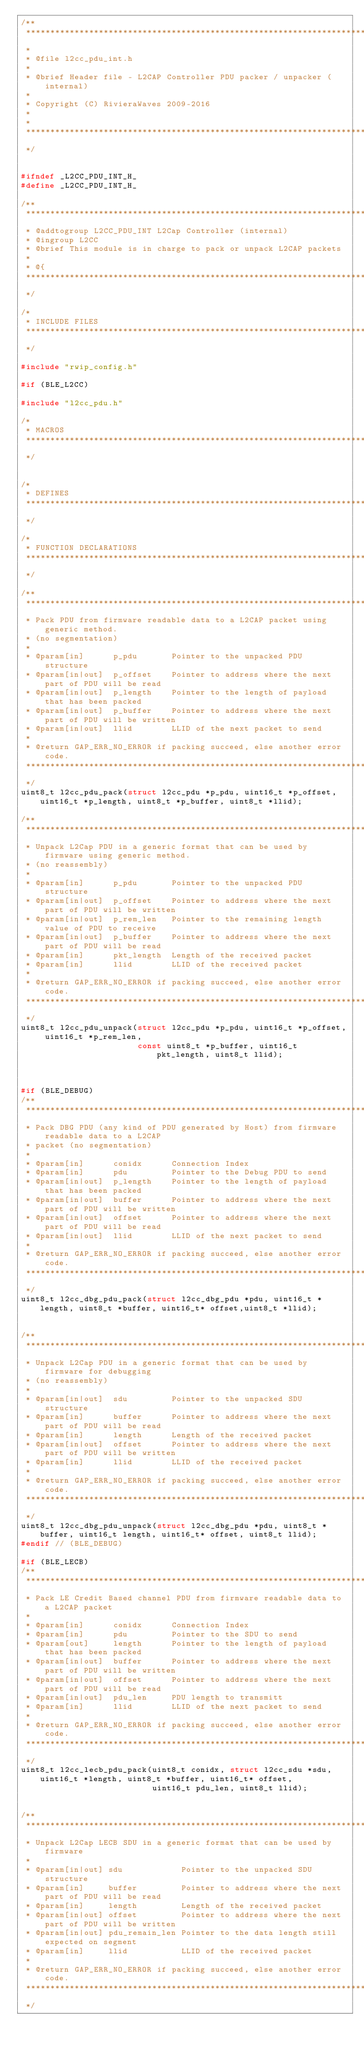<code> <loc_0><loc_0><loc_500><loc_500><_C_>/**
 ****************************************************************************************
 *
 * @file l2cc_pdu_int.h
 *
 * @brief Header file - L2CAP Controller PDU packer / unpacker (internal)
 *
 * Copyright (C) RivieraWaves 2009-2016
 *
 *
 ****************************************************************************************
 */


#ifndef _L2CC_PDU_INT_H_
#define _L2CC_PDU_INT_H_

/**
 ****************************************************************************************
 * @addtogroup L2CC_PDU_INT L2Cap Controller (internal)
 * @ingroup L2CC
 * @brief This module is in charge to pack or unpack L2CAP packets
 *
 * @{
 ****************************************************************************************
 */

/*
 * INCLUDE FILES
 ****************************************************************************************
 */

#include "rwip_config.h"

#if (BLE_L2CC)

#include "l2cc_pdu.h"

/*
 * MACROS
 ****************************************************************************************
 */


/*
 * DEFINES
 ****************************************************************************************
 */

/*
 * FUNCTION DECLARATIONS
 ****************************************************************************************
 */

/**
 ****************************************************************************************
 * Pack PDU from firmware readable data to a L2CAP packet using generic method.
 * (no segmentation)
 *
 * @param[in]      p_pdu       Pointer to the unpacked PDU structure
 * @param[in|out]  p_offset    Pointer to address where the next part of PDU will be read
 * @param[in|out]  p_length    Pointer to the length of payload that has been packed
 * @param[in|out]  p_buffer    Pointer to address where the next part of PDU will be written
 * @param[in|out]  llid        LLID of the next packet to send
 *
 * @return GAP_ERR_NO_ERROR if packing succeed, else another error code.
 ****************************************************************************************
 */
uint8_t l2cc_pdu_pack(struct l2cc_pdu *p_pdu, uint16_t *p_offset, uint16_t *p_length, uint8_t *p_buffer, uint8_t *llid);

/**
 ****************************************************************************************
 * Unpack L2Cap PDU in a generic format that can be used by firmware using generic method.
 * (no reassembly)
 *
 * @param[in]      p_pdu       Pointer to the unpacked PDU structure
 * @param[in|out]  p_offset    Pointer to address where the next part of PDU will be written
 * @param[in|out]  p_rem_len   Pointer to the remaining length value of PDU to receive
 * @param[in|out]  p_buffer    Pointer to address where the next part of PDU will be read
 * @param[in]      pkt_length  Length of the received packet
 * @param[in]      llid        LLID of the received packet
 *
 * @return GAP_ERR_NO_ERROR if packing succeed, else another error code.
 ****************************************************************************************
 */
uint8_t l2cc_pdu_unpack(struct l2cc_pdu *p_pdu, uint16_t *p_offset, uint16_t *p_rem_len,
                        const uint8_t *p_buffer, uint16_t pkt_length, uint8_t llid);



#if (BLE_DEBUG)
/**
 ****************************************************************************************
 * Pack DBG PDU (any kind of PDU generated by Host) from firmware readable data to a L2CAP
 * packet (no segmentation)
 *
 * @param[in]      conidx      Connection Index
 * @param[in]      pdu         Pointer to the Debug PDU to send
 * @param[in|out]  p_length    Pointer to the length of payload that has been packed
 * @param[in|out]  buffer      Pointer to address where the next part of PDU will be written
 * @param[in|out]  offset      Pointer to address where the next part of PDU will be read
 * @param[in|out]  llid        LLID of the next packet to send
 *
 * @return GAP_ERR_NO_ERROR if packing succeed, else another error code.
 ****************************************************************************************
 */
uint8_t l2cc_dbg_pdu_pack(struct l2cc_dbg_pdu *pdu, uint16_t *length, uint8_t *buffer, uint16_t* offset,uint8_t *llid);


/**
 ****************************************************************************************
 * Unpack L2Cap PDU in a generic format that can be used by firmware for debugging
 * (no reassembly)
 *
 * @param[in|out]  sdu         Pointer to the unpacked SDU structure
 * @param[in]      buffer      Pointer to address where the next part of PDU will be read
 * @param[in]      length      Length of the received packet
 * @param[in|out]  offset      Pointer to address where the next part of PDU will be written
 * @param[in]      llid        LLID of the received packet
 *
 * @return GAP_ERR_NO_ERROR if packing succeed, else another error code.
 ****************************************************************************************
 */
uint8_t l2cc_dbg_pdu_unpack(struct l2cc_dbg_pdu *pdu, uint8_t *buffer, uint16_t length, uint16_t* offset, uint8_t llid);
#endif // (BLE_DEBUG)

#if (BLE_LECB)
/**
 ****************************************************************************************
 * Pack LE Credit Based channel PDU from firmware readable data to a L2CAP packet
 *
 * @param[in]      conidx      Connection Index
 * @param[in]      pdu         Pointer to the SDU to send
 * @param[out]     length      Pointer to the length of payload that has been packed
 * @param[in|out]  buffer      Pointer to address where the next part of PDU will be written
 * @param[in|out]  offset      Pointer to address where the next part of PDU will be read
 * @param[in|out]  pdu_len     PDU length to transmitt
 * @param[in]      llid        LLID of the next packet to send
 *
 * @return GAP_ERR_NO_ERROR if packing succeed, else another error code.
 ****************************************************************************************
 */
uint8_t l2cc_lecb_pdu_pack(uint8_t conidx, struct l2cc_sdu *sdu, uint16_t *length, uint8_t *buffer, uint16_t* offset,
                           uint16_t pdu_len, uint8_t llid);


/**
 ****************************************************************************************
 * Unpack L2Cap LECB SDU in a generic format that can be used by firmware
 *
 * @param[in|out] sdu            Pointer to the unpacked SDU structure
 * @param[in]     buffer         Pointer to address where the next part of PDU will be read
 * @param[in]     length         Length of the received packet
 * @param[in|out] offset         Pointer to address where the next part of PDU will be written
 * @param[in|out] pdu_remain_len Pointer to the data length still expected on segment
 * @param[in]     llid           LLID of the received packet
 *
 * @return GAP_ERR_NO_ERROR if packing succeed, else another error code.
 ****************************************************************************************
 */</code> 